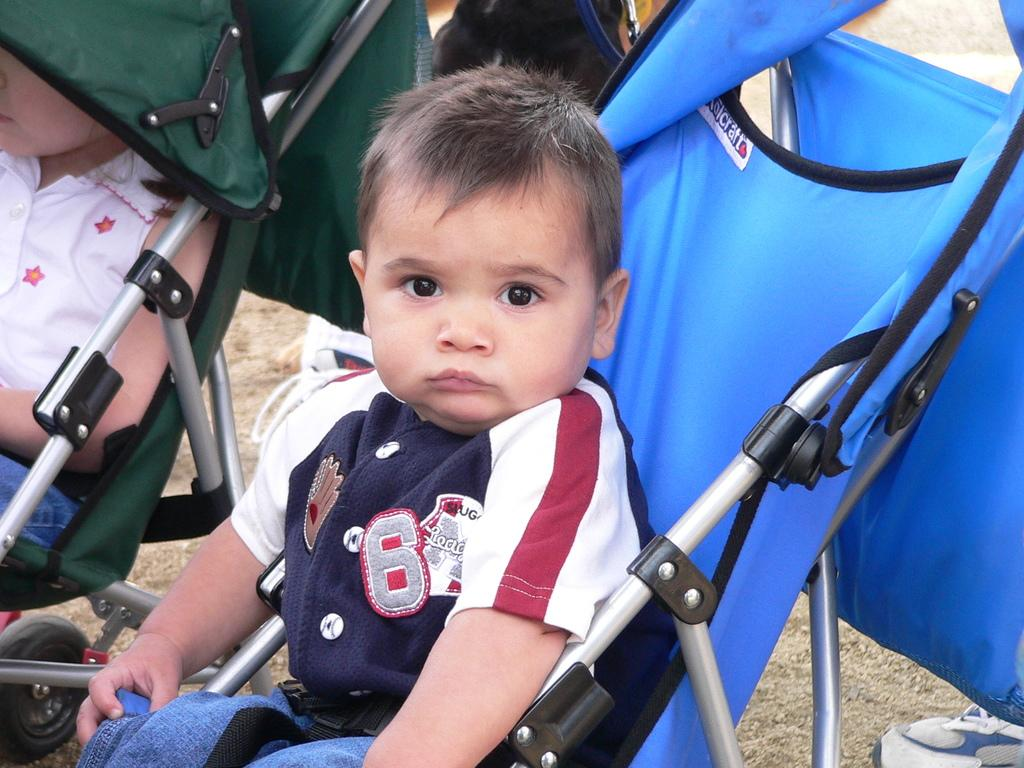How many babies are present in the image? There are two babies in the image. What are the babies doing in the image? The babies are sitting on chairs. Can you describe any other objects or elements in the image? A shoe is visible at the bottom of the image. What type of writing can be seen on the chair the babies are sitting on? There is no writing visible on the chairs in the image. 